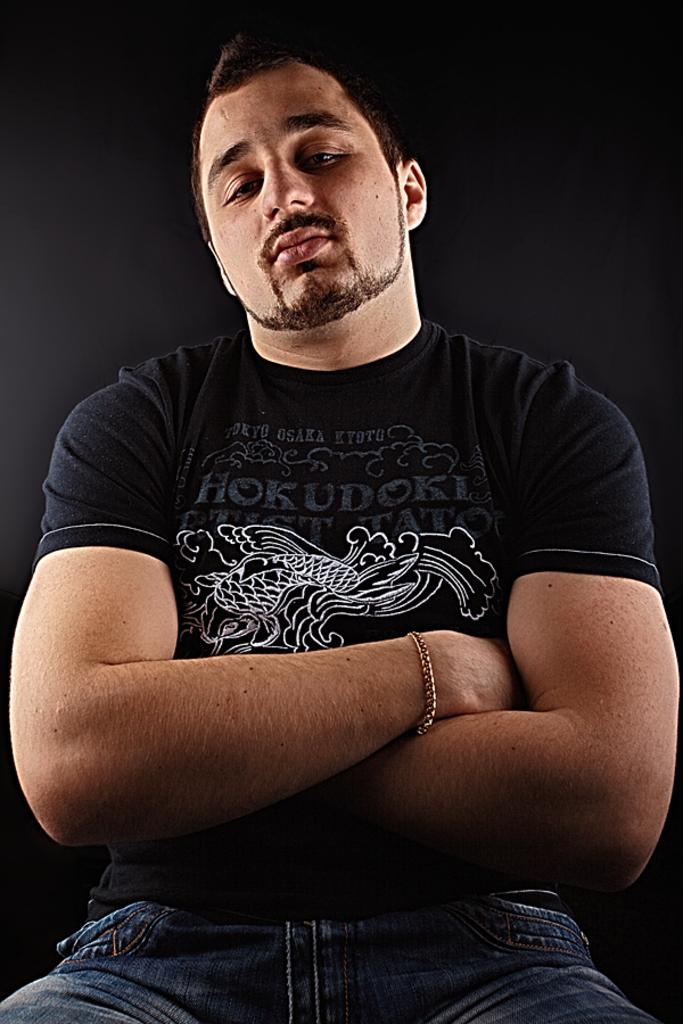Who is present in the image? There is a man in the image. What is the man wearing in the image? The man is wearing a bracelet. What can be observed about the background of the image? The background of the image is dark. What type of owl can be seen in the company of the man in the image? There is no owl present in the image, and the man is not shown to be in the company of any animals. 